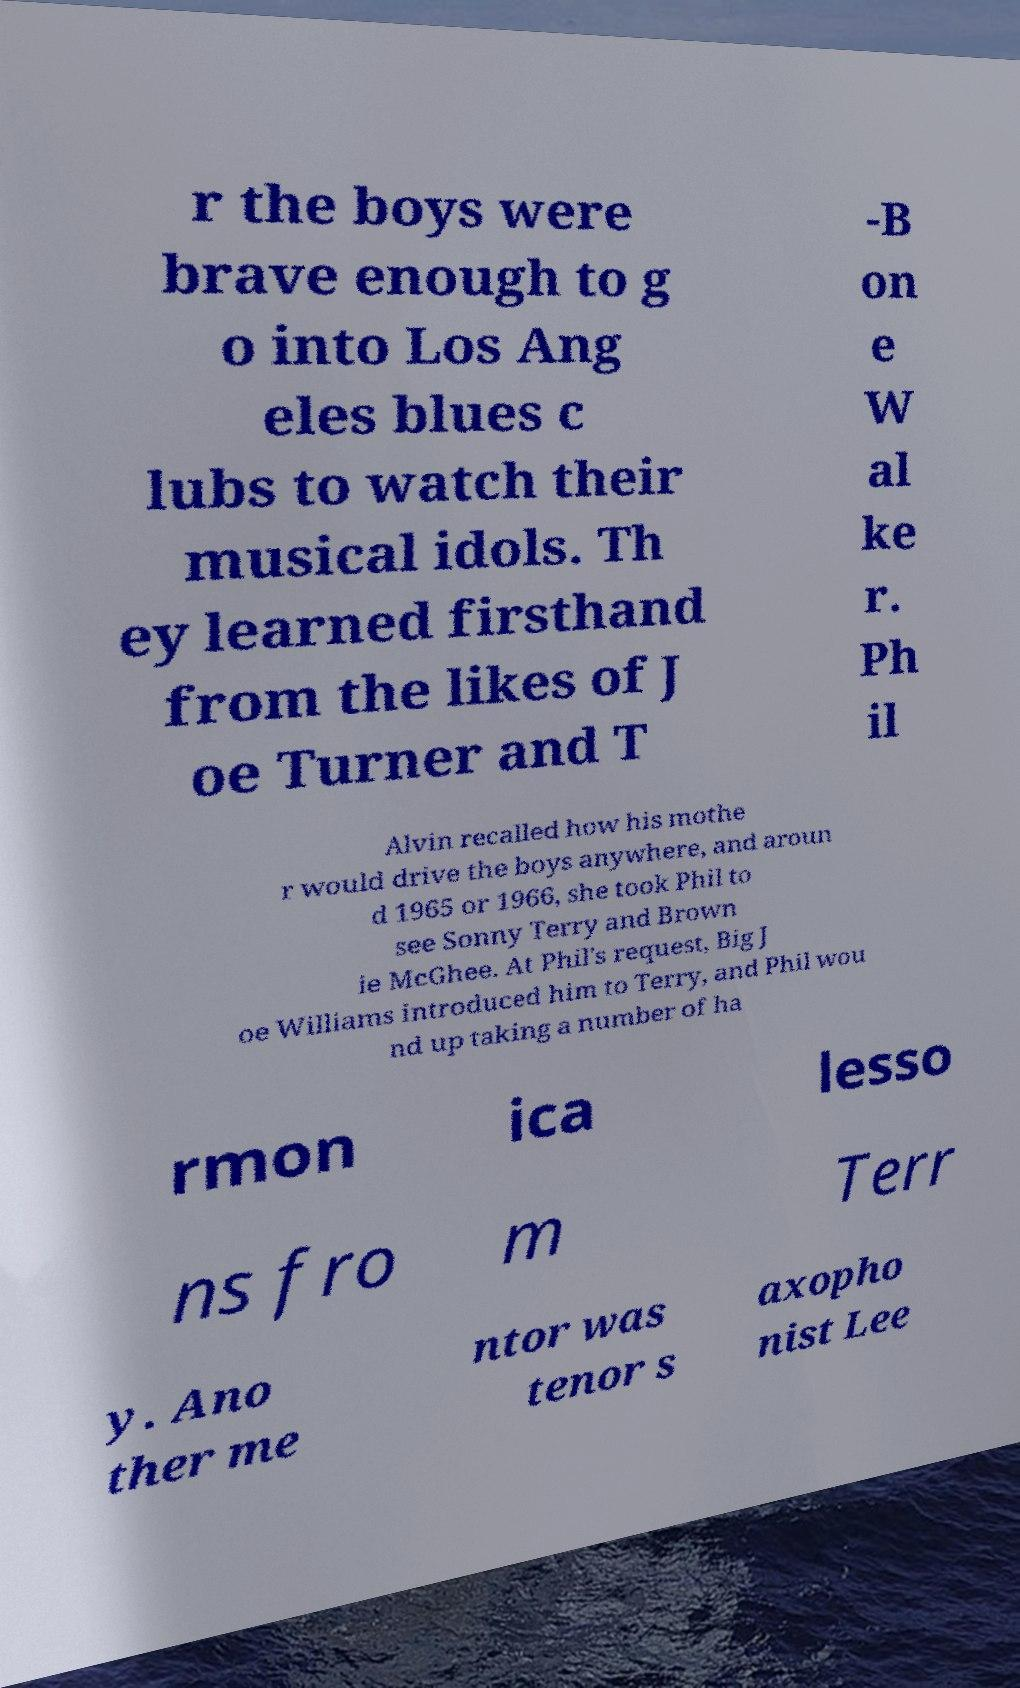Please read and relay the text visible in this image. What does it say? r the boys were brave enough to g o into Los Ang eles blues c lubs to watch their musical idols. Th ey learned firsthand from the likes of J oe Turner and T -B on e W al ke r. Ph il Alvin recalled how his mothe r would drive the boys anywhere, and aroun d 1965 or 1966, she took Phil to see Sonny Terry and Brown ie McGhee. At Phil's request, Big J oe Williams introduced him to Terry, and Phil wou nd up taking a number of ha rmon ica lesso ns fro m Terr y. Ano ther me ntor was tenor s axopho nist Lee 